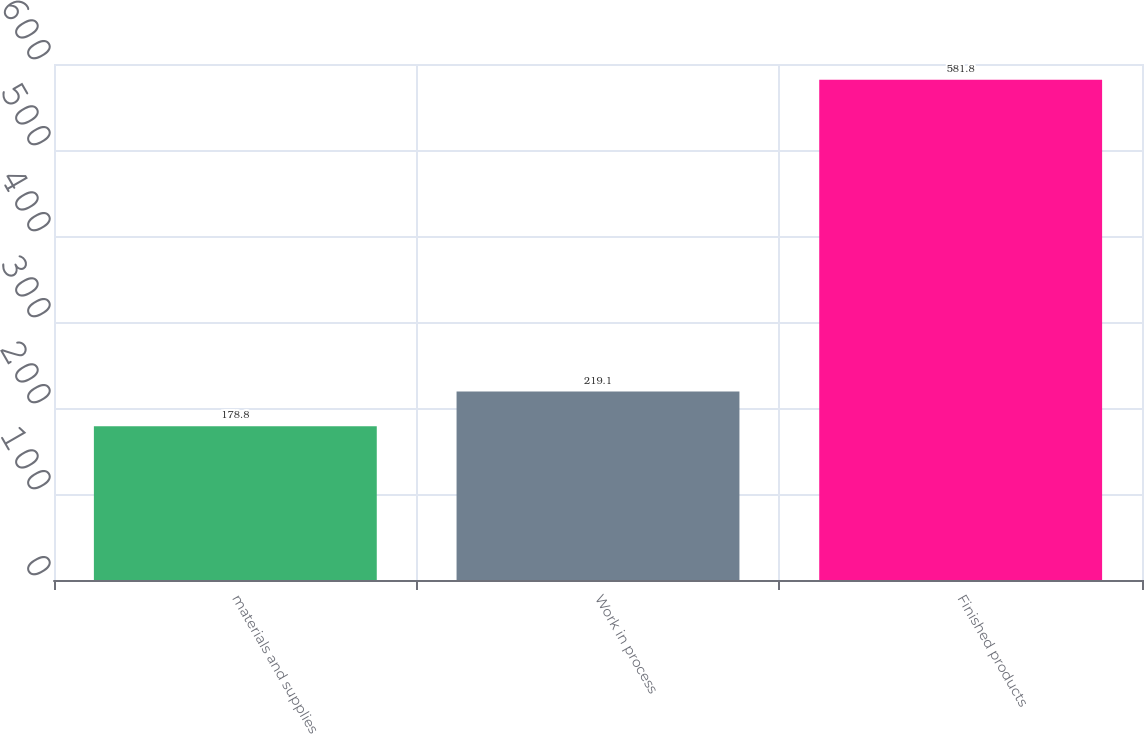Convert chart to OTSL. <chart><loc_0><loc_0><loc_500><loc_500><bar_chart><fcel>materials and supplies<fcel>Work in process<fcel>Finished products<nl><fcel>178.8<fcel>219.1<fcel>581.8<nl></chart> 